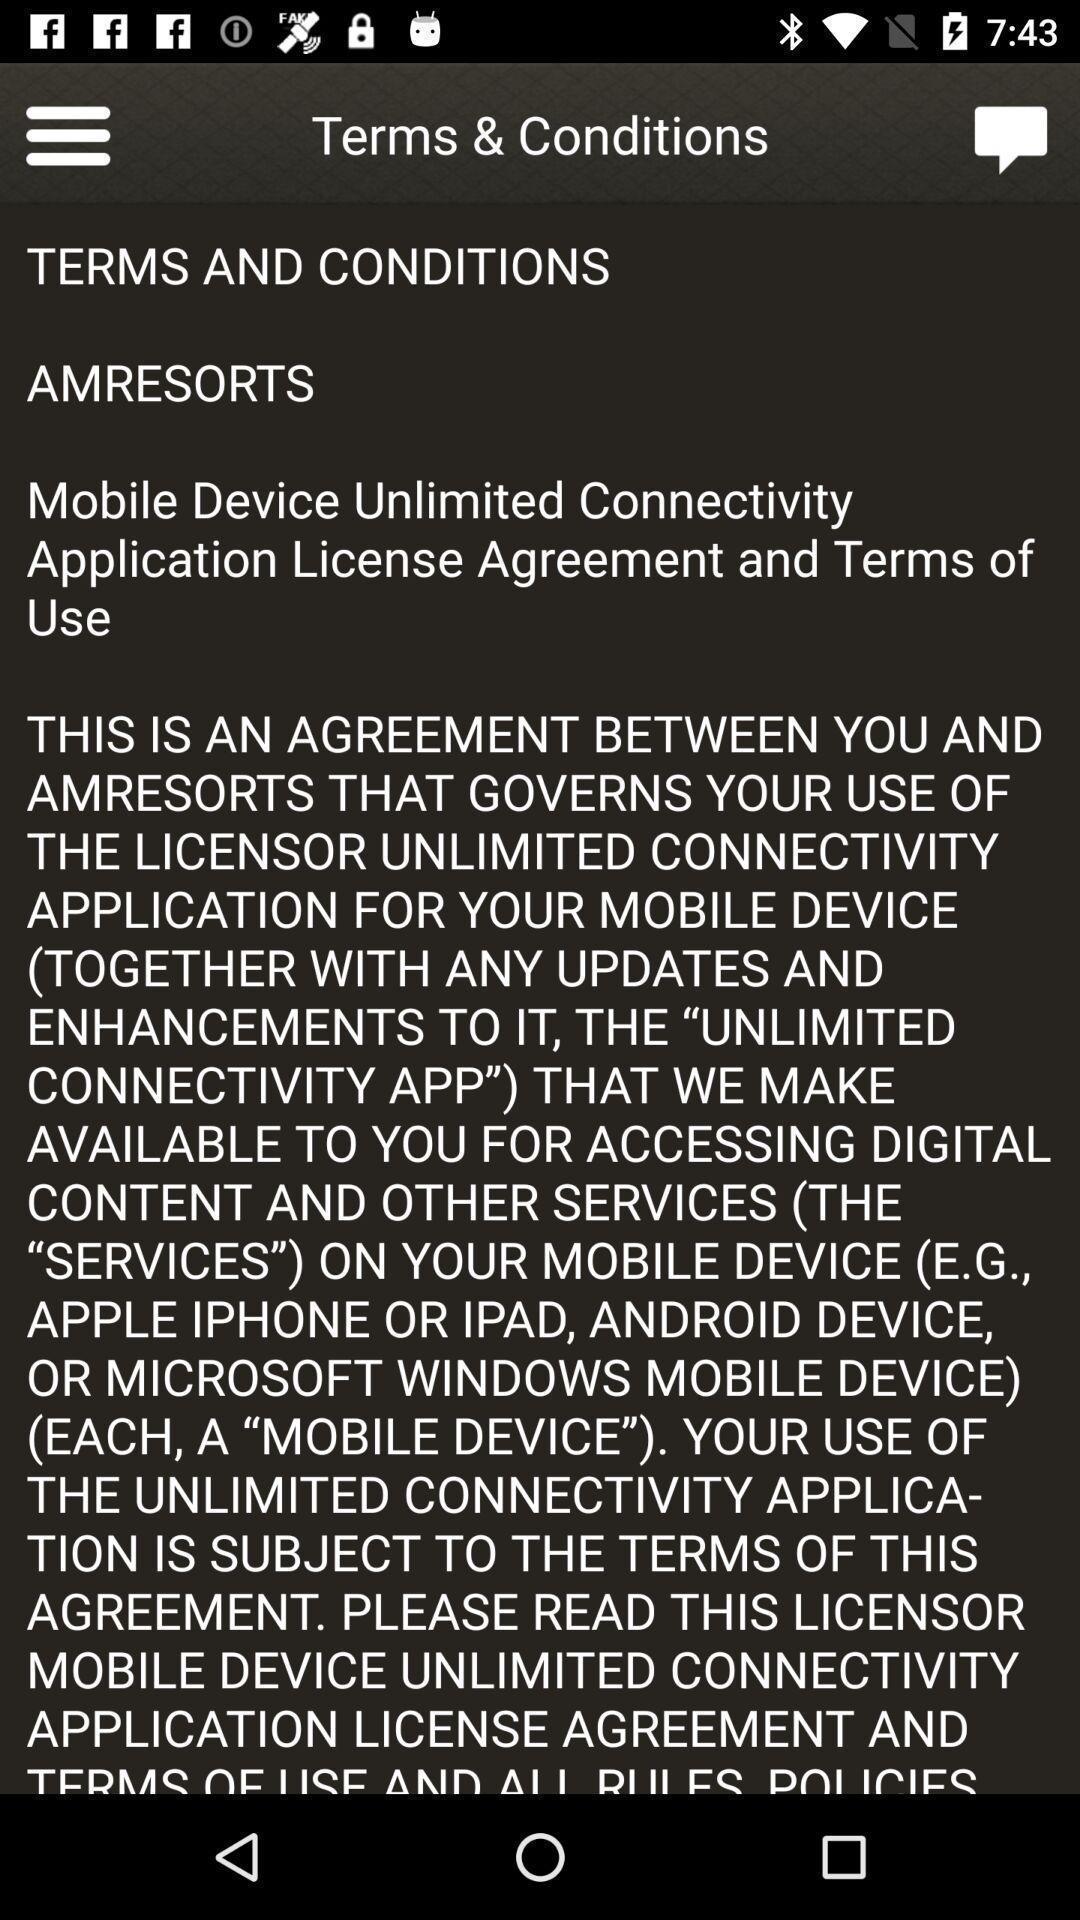Tell me what you see in this picture. Screen displaying the terms and conditions. 